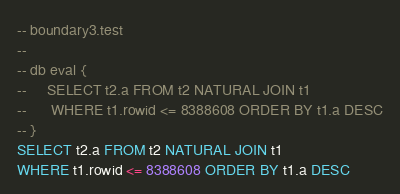Convert code to text. <code><loc_0><loc_0><loc_500><loc_500><_SQL_>-- boundary3.test
-- 
-- db eval {
--     SELECT t2.a FROM t2 NATURAL JOIN t1
--      WHERE t1.rowid <= 8388608 ORDER BY t1.a DESC
-- }
SELECT t2.a FROM t2 NATURAL JOIN t1
WHERE t1.rowid <= 8388608 ORDER BY t1.a DESC</code> 